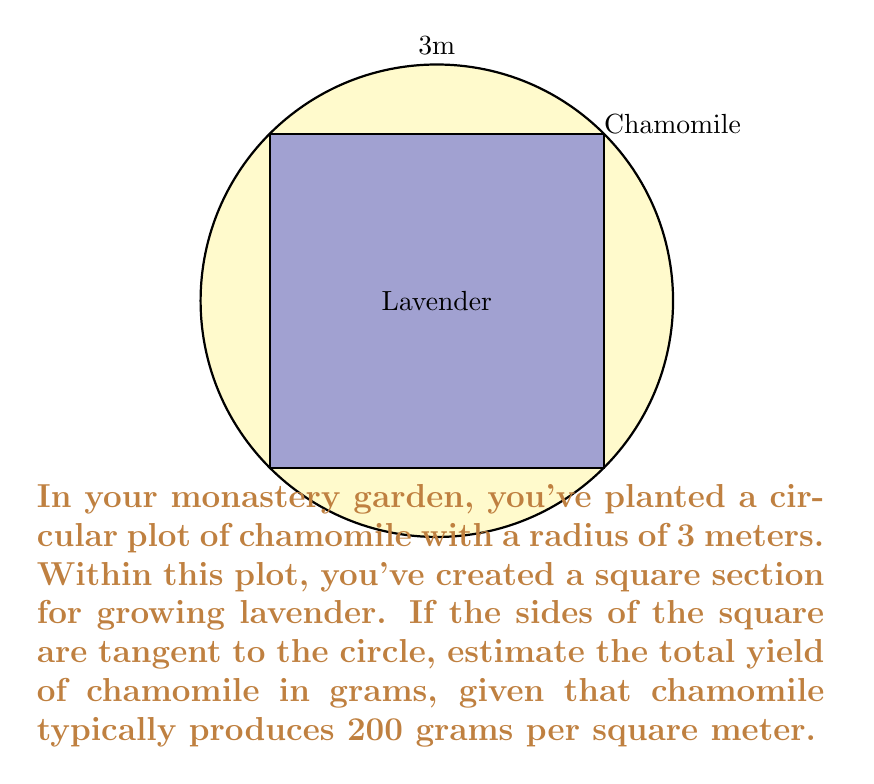Show me your answer to this math problem. Let's approach this step-by-step:

1) The area of the circular plot is given by $A_c = \pi r^2$
   $A_c = \pi * 3^2 = 9\pi$ square meters

2) To find the area of the square lavender plot, we need to calculate its side length.
   In a circle with radius $r$, the side of an inscribed square is $s = r\sqrt{2}$
   $s = 3\sqrt{2}$ meters

3) The area of the square lavender plot is:
   $A_s = s^2 = (3\sqrt{2})^2 = 18$ square meters

4) The area planted with chamomile is the difference between the circle and square areas:
   $A_{chamomile} = A_c - A_s = 9\pi - 18$ square meters

5) Given the yield of 200 grams per square meter, the total yield is:
   $\text{Yield} = 200 * (9\pi - 18)$ grams
   $= 1800\pi - 3600$ grams
   $\approx 2051.33$ grams
Answer: $1800\pi - 3600$ grams (or approximately 2051 grams) 